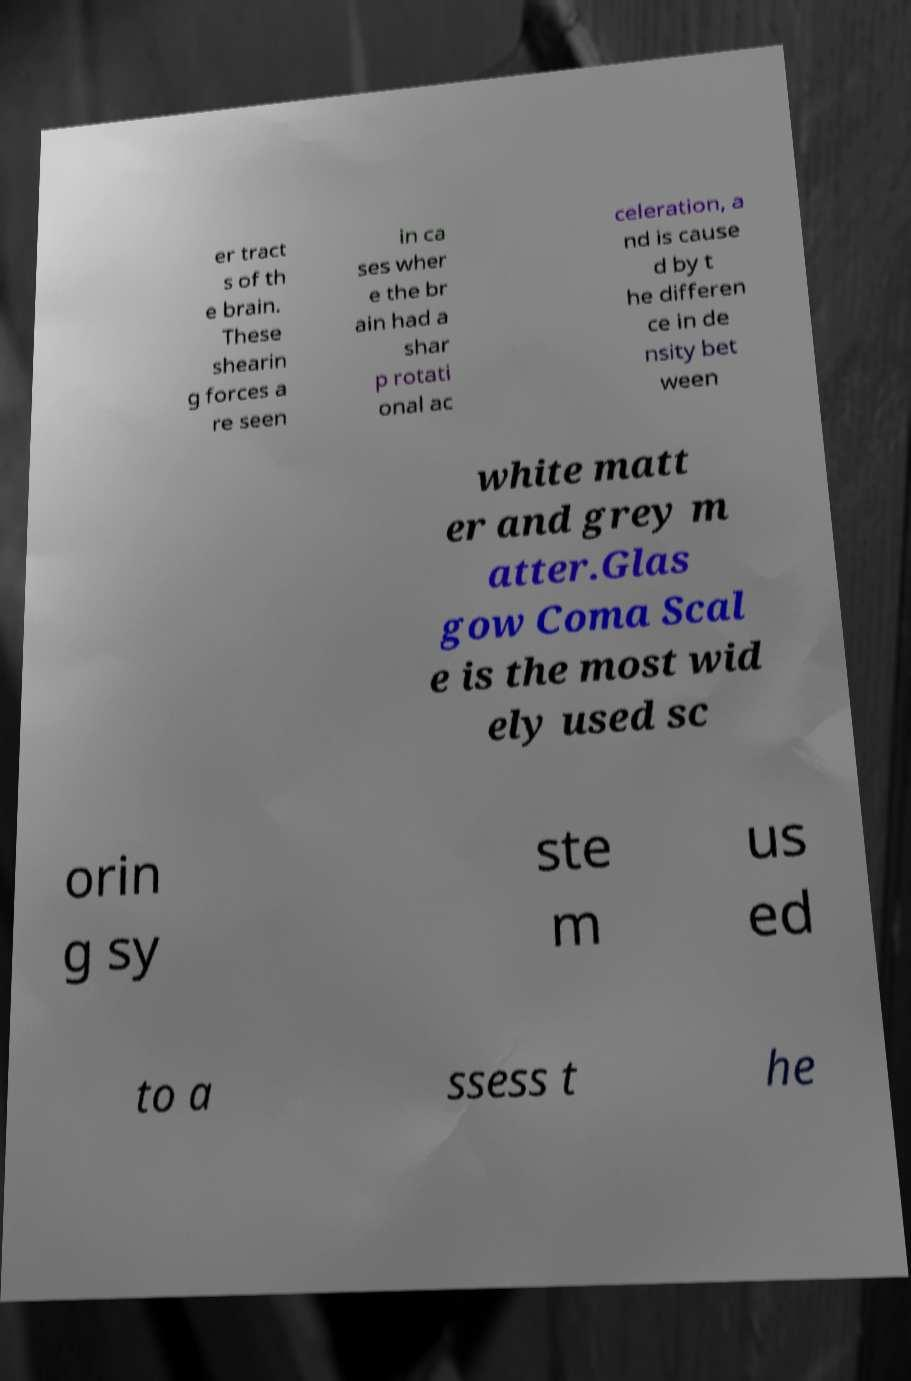Can you read and provide the text displayed in the image?This photo seems to have some interesting text. Can you extract and type it out for me? er tract s of th e brain. These shearin g forces a re seen in ca ses wher e the br ain had a shar p rotati onal ac celeration, a nd is cause d by t he differen ce in de nsity bet ween white matt er and grey m atter.Glas gow Coma Scal e is the most wid ely used sc orin g sy ste m us ed to a ssess t he 